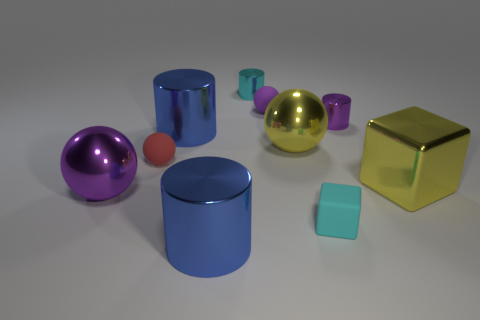Are the tiny purple sphere and the big cube made of the same material?
Offer a terse response. No. Are there any tiny rubber cubes that are in front of the matte object that is in front of the metallic ball to the left of the tiny purple sphere?
Make the answer very short. No. Do the rubber block and the big cube have the same color?
Offer a terse response. No. Are there fewer shiny objects than small purple cylinders?
Offer a terse response. No. Does the large cylinder that is behind the small red rubber sphere have the same material as the small cyan object that is behind the tiny cyan cube?
Your answer should be very brief. Yes. Are there fewer small purple cylinders left of the tiny cyan matte object than small red objects?
Your response must be concise. Yes. How many small cyan objects are in front of the small cyan shiny cylinder behind the purple shiny cylinder?
Offer a terse response. 1. There is a matte thing that is right of the tiny red thing and behind the yellow cube; what size is it?
Your answer should be compact. Small. Are there any other things that are the same material as the yellow block?
Your response must be concise. Yes. Is the material of the small cyan cylinder the same as the blue object that is in front of the large yellow cube?
Your answer should be very brief. Yes. 